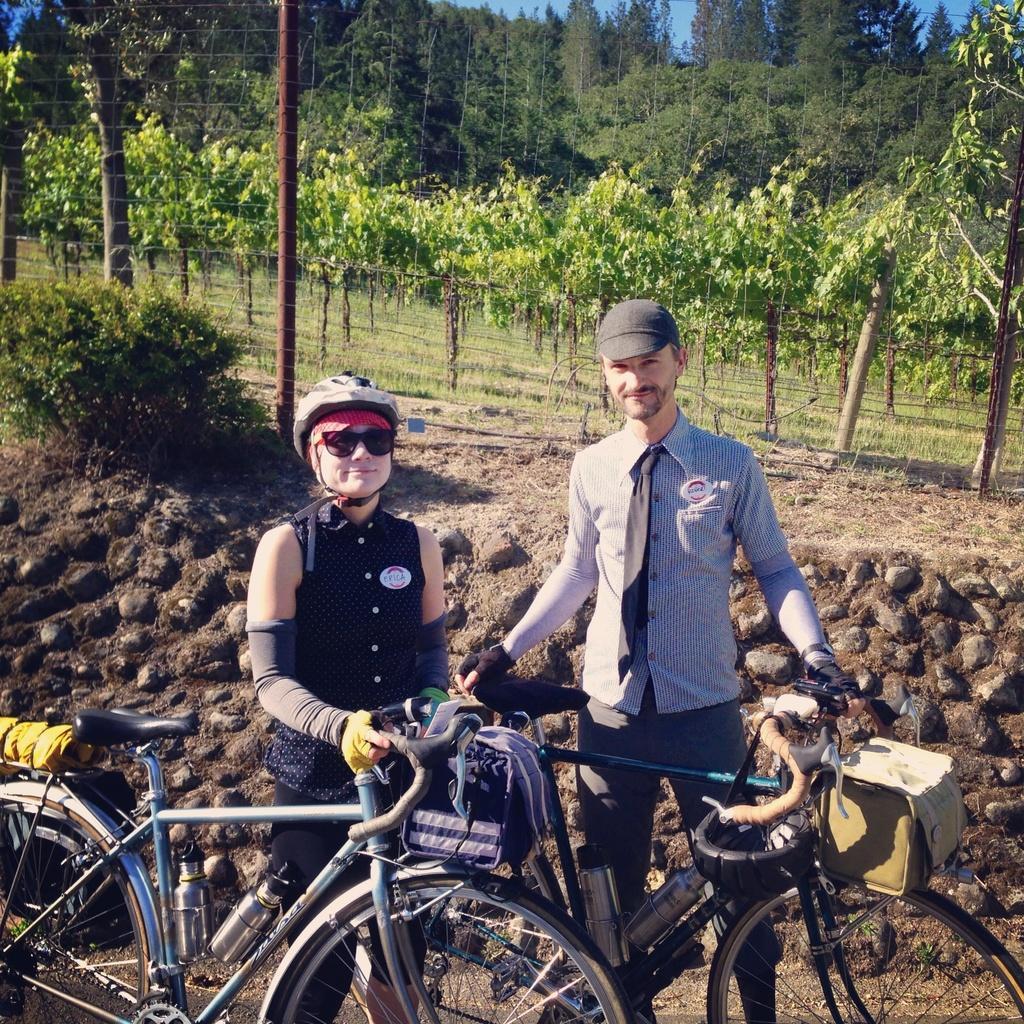Please provide a concise description of this image. In this image we can see two persons are standing on the ground and they are smiling. Here we can see bicycles, bags, poles, plants, and grass. In the background there are trees and sky. 